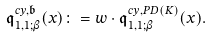Convert formula to latex. <formula><loc_0><loc_0><loc_500><loc_500>\mathfrak { q } _ { 1 , 1 ; \beta } ^ { c y , \mathfrak { b } } ( x ) \colon = w \cdot \mathfrak { q } _ { 1 , 1 ; \beta } ^ { c y , P D ( K ) } ( x ) .</formula> 